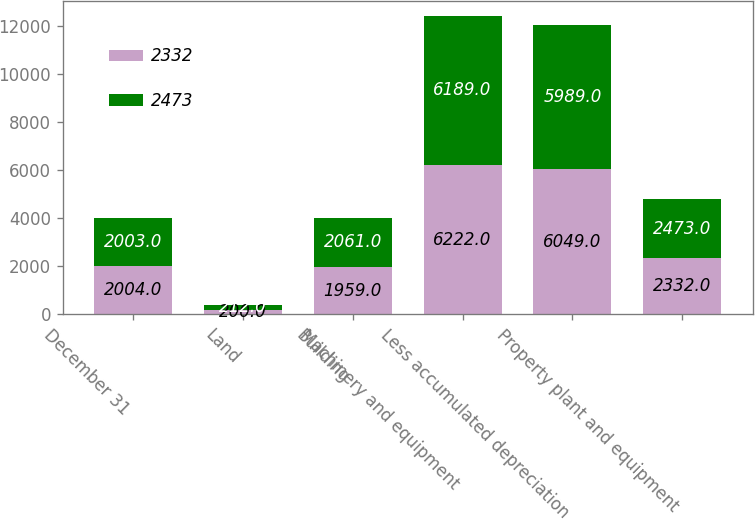Convert chart. <chart><loc_0><loc_0><loc_500><loc_500><stacked_bar_chart><ecel><fcel>December 31<fcel>Land<fcel>Building<fcel>Machinery and equipment<fcel>Less accumulated depreciation<fcel>Property plant and equipment<nl><fcel>2332<fcel>2004<fcel>200<fcel>1959<fcel>6222<fcel>6049<fcel>2332<nl><fcel>2473<fcel>2003<fcel>212<fcel>2061<fcel>6189<fcel>5989<fcel>2473<nl></chart> 